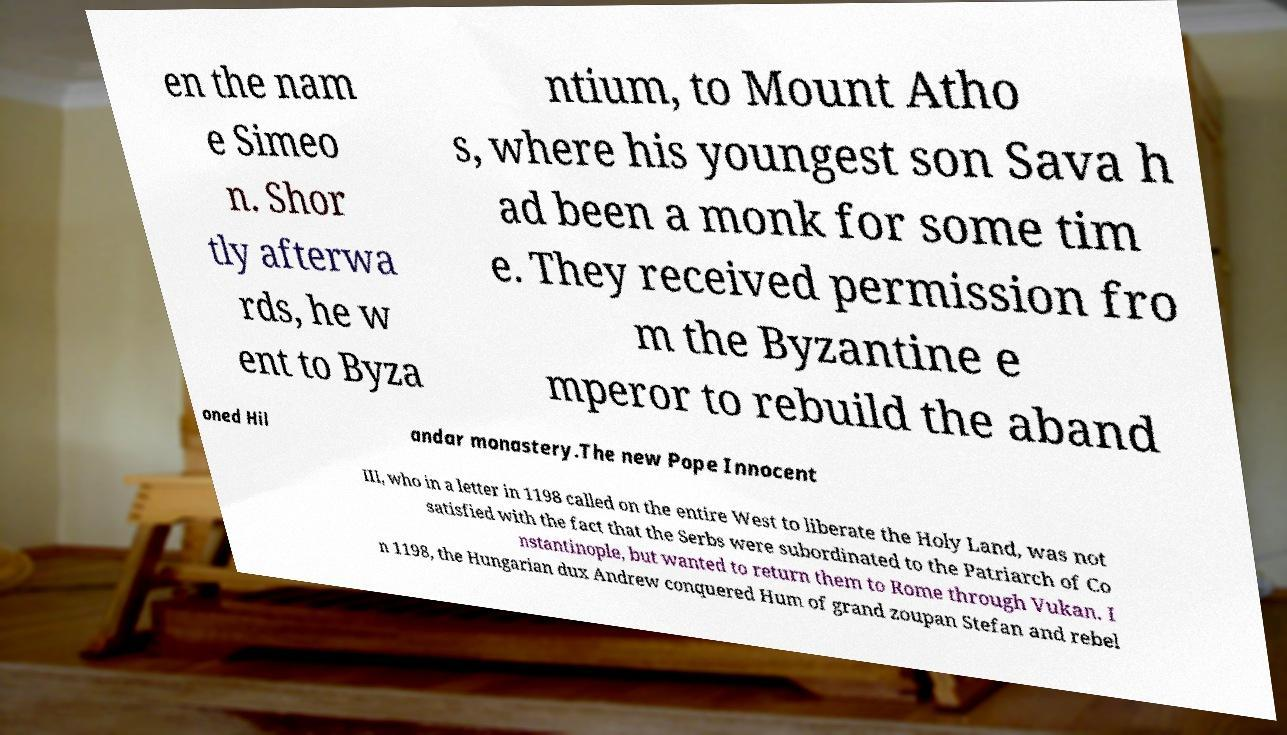Can you accurately transcribe the text from the provided image for me? en the nam e Simeo n. Shor tly afterwa rds, he w ent to Byza ntium, to Mount Atho s, where his youngest son Sava h ad been a monk for some tim e. They received permission fro m the Byzantine e mperor to rebuild the aband oned Hil andar monastery.The new Pope Innocent III, who in a letter in 1198 called on the entire West to liberate the Holy Land, was not satisfied with the fact that the Serbs were subordinated to the Patriarch of Co nstantinople, but wanted to return them to Rome through Vukan. I n 1198, the Hungarian dux Andrew conquered Hum of grand zoupan Stefan and rebel 